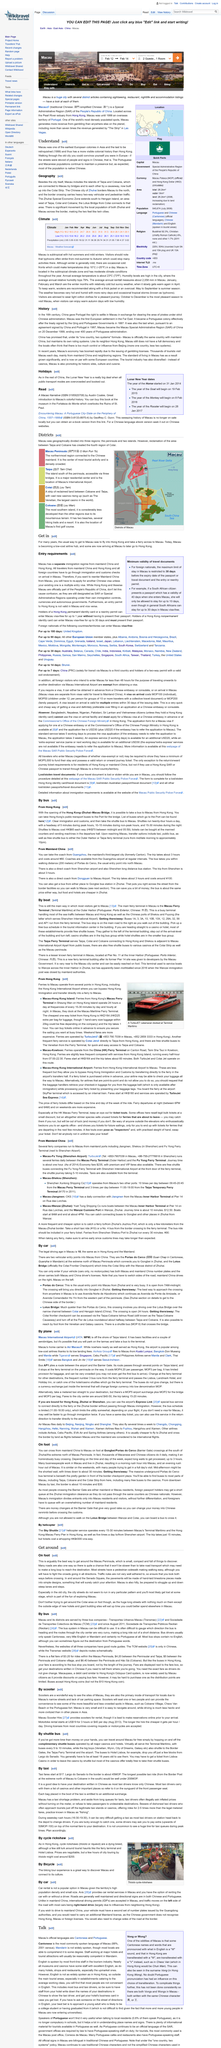Specify some key components in this picture. The majority of the population in Macau is Chinese, and therefore, the majority of the population in Macau is native Chinese. Macau is home to a variety of nationalities, including the Portuguese and Macanese, who maintain a significant presence in the region. In 1999, Macau ceased to be a European colony. 